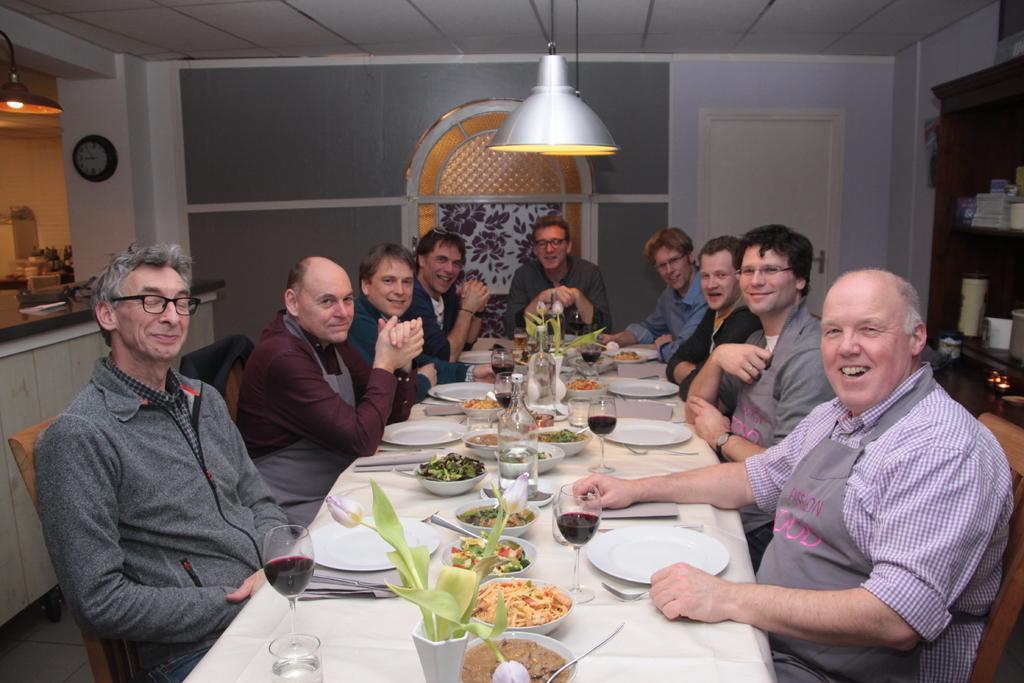Can you describe this image briefly? In the image we can see there are people who are sitting on chair and in front of them there is a table on which there are food in the bowl and wine glasses. 